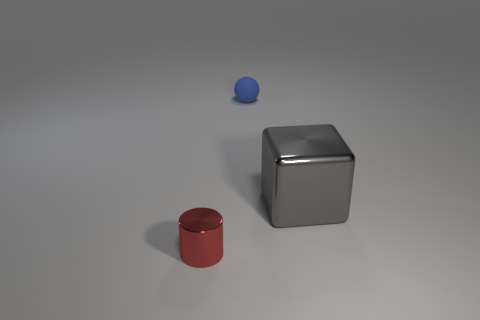Is there any other thing that is the same size as the gray object?
Your answer should be very brief. No. How many metallic objects are to the right of the small object that is behind the red shiny cylinder?
Your answer should be compact. 1. Is there a tiny cylinder?
Your answer should be compact. Yes. What number of other objects are the same color as the small metallic cylinder?
Keep it short and to the point. 0. Are there fewer red objects than small purple matte cubes?
Your answer should be compact. No. There is a tiny object behind the metal object that is behind the small red cylinder; what is its shape?
Keep it short and to the point. Sphere. Are there any matte objects in front of the red object?
Your response must be concise. No. There is a rubber object that is the same size as the red metallic cylinder; what color is it?
Offer a very short reply. Blue. How many gray cubes have the same material as the red thing?
Give a very brief answer. 1. What number of other things are the same size as the cube?
Your answer should be very brief. 0. 